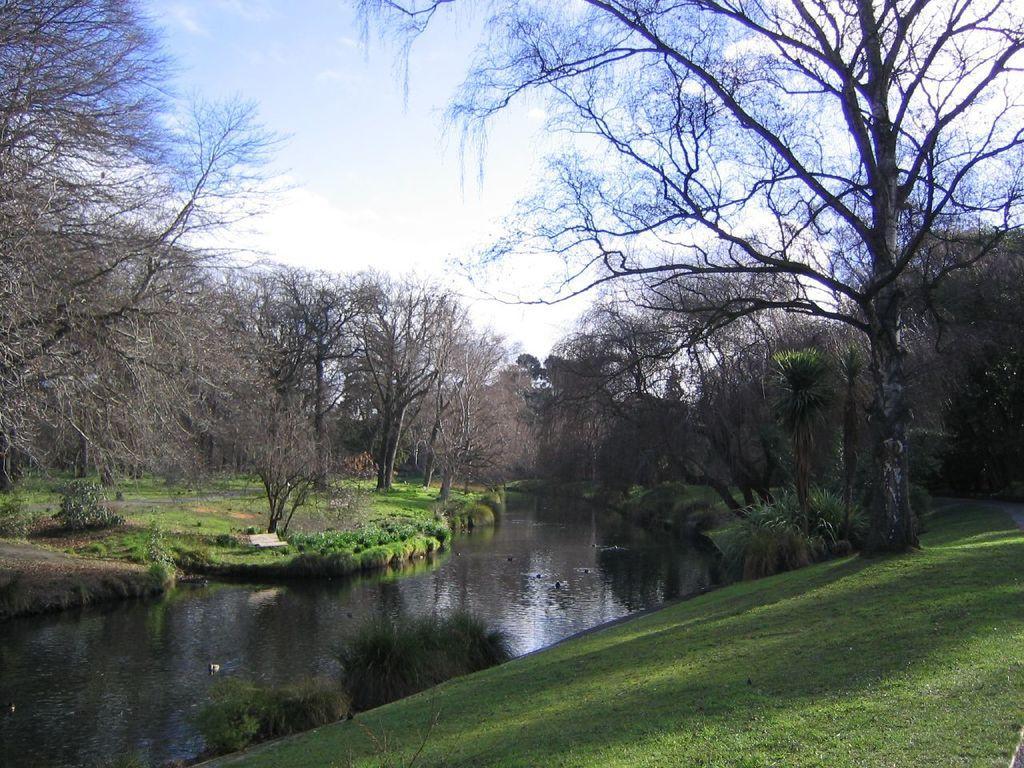How would you summarize this image in a sentence or two? In this image I can see grass, shadows, number of trees, water and bushes. In the background I can see the sky. 